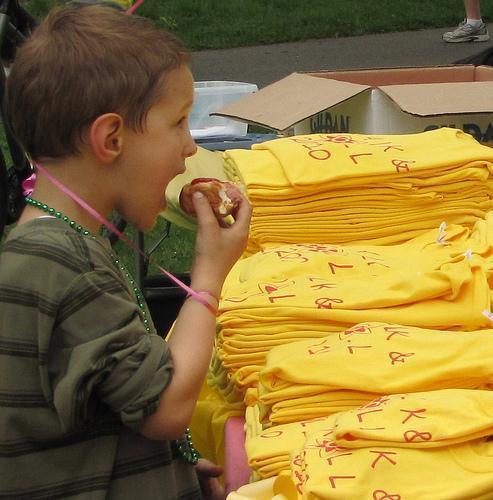How many people are there?
Give a very brief answer. 1. 